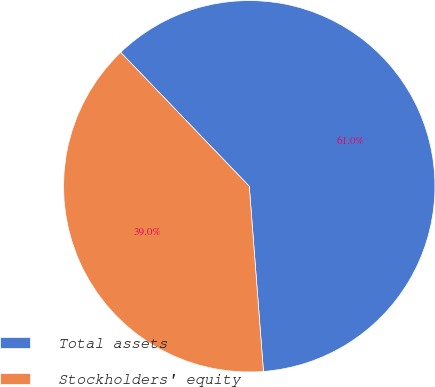Convert chart to OTSL. <chart><loc_0><loc_0><loc_500><loc_500><pie_chart><fcel>Total assets<fcel>Stockholders' equity<nl><fcel>60.96%<fcel>39.04%<nl></chart> 